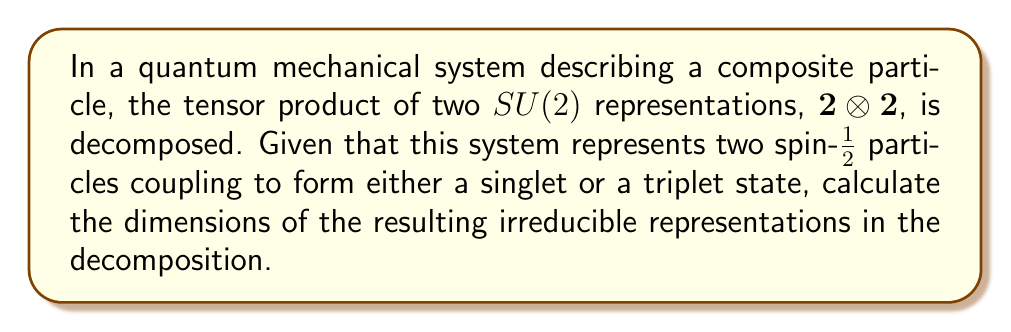Give your solution to this math problem. 1. In $SU(2)$, the fundamental representation $\mathbf{2}$ corresponds to spin-1/2 particles.

2. The tensor product $\mathbf{2} \otimes \mathbf{2}$ represents the coupling of two spin-1/2 particles.

3. Using the Clebsch-Gordan series for $SU(2)$, we can decompose this tensor product:

   $$\mathbf{2} \otimes \mathbf{2} = \mathbf{1} \oplus \mathbf{3}$$

4. Here, $\mathbf{1}$ represents the singlet state (total spin 0), and $\mathbf{3}$ represents the triplet state (total spin 1).

5. The dimension of the singlet representation $\mathbf{1}$ is 1.

6. The dimension of the triplet representation $\mathbf{3}$ is 3.

7. Therefore, the dimensions of the resulting irreducible representations are 1 and 3.
Answer: 1 and 3 